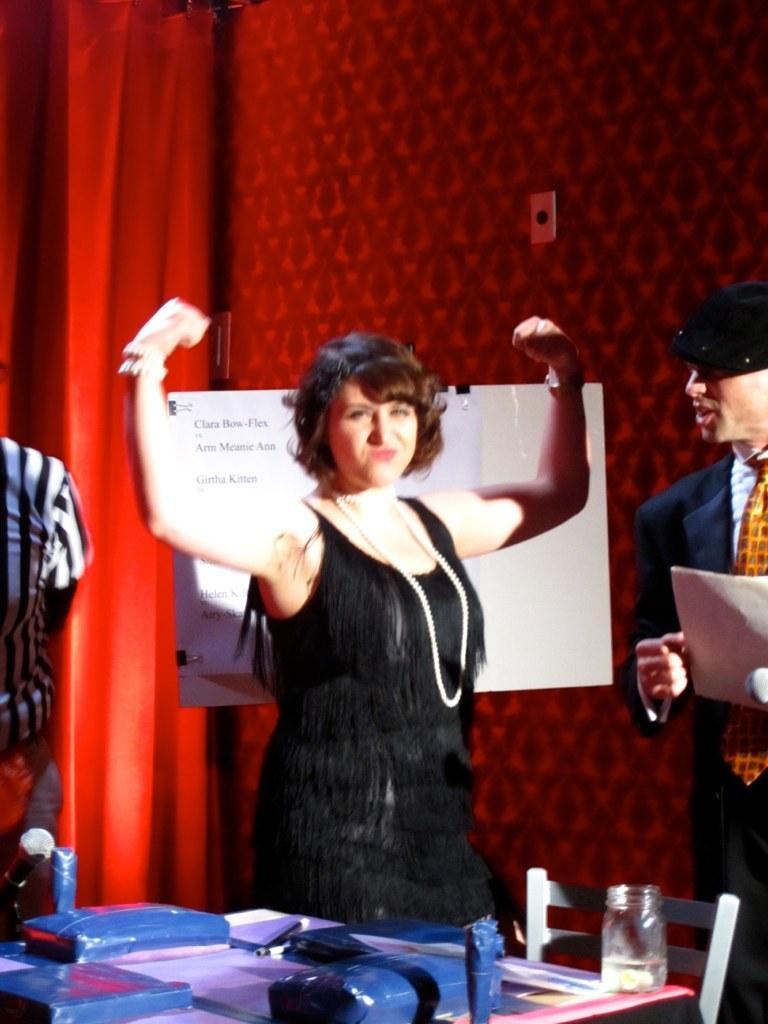How would you summarize this image in a sentence or two? In this image we can see three persons, among them one person is holding an object, there is a chair and a table, on the table, we can see some objects, also we can see a board with some text, in the background we can see a curtain and the wall. 